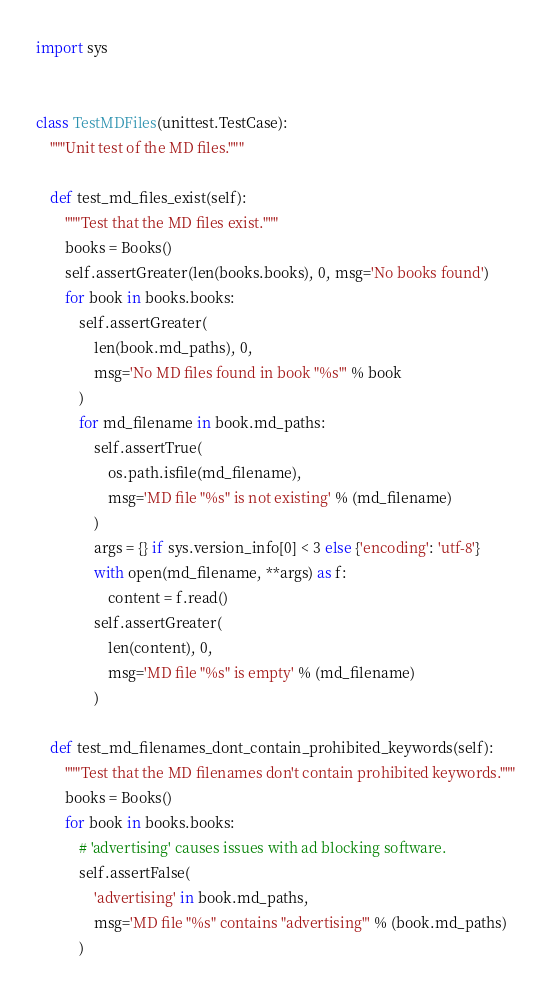Convert code to text. <code><loc_0><loc_0><loc_500><loc_500><_Python_>import sys


class TestMDFiles(unittest.TestCase):
    """Unit test of the MD files."""

    def test_md_files_exist(self):
        """Test that the MD files exist."""
        books = Books()
        self.assertGreater(len(books.books), 0, msg='No books found')
        for book in books.books:
            self.assertGreater(
                len(book.md_paths), 0,
                msg='No MD files found in book "%s"' % book
            )
            for md_filename in book.md_paths:
                self.assertTrue(
                    os.path.isfile(md_filename),
                    msg='MD file "%s" is not existing' % (md_filename)
                )
                args = {} if sys.version_info[0] < 3 else {'encoding': 'utf-8'}
                with open(md_filename, **args) as f:
                    content = f.read()
                self.assertGreater(
                    len(content), 0,
                    msg='MD file "%s" is empty' % (md_filename)
                )

    def test_md_filenames_dont_contain_prohibited_keywords(self):
        """Test that the MD filenames don't contain prohibited keywords."""
        books = Books()
        for book in books.books:
            # 'advertising' causes issues with ad blocking software.
            self.assertFalse(
                'advertising' in book.md_paths,
                msg='MD file "%s" contains "advertising"' % (book.md_paths)
            )
</code> 